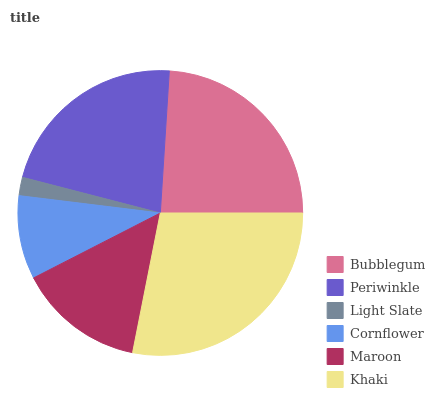Is Light Slate the minimum?
Answer yes or no. Yes. Is Khaki the maximum?
Answer yes or no. Yes. Is Periwinkle the minimum?
Answer yes or no. No. Is Periwinkle the maximum?
Answer yes or no. No. Is Bubblegum greater than Periwinkle?
Answer yes or no. Yes. Is Periwinkle less than Bubblegum?
Answer yes or no. Yes. Is Periwinkle greater than Bubblegum?
Answer yes or no. No. Is Bubblegum less than Periwinkle?
Answer yes or no. No. Is Periwinkle the high median?
Answer yes or no. Yes. Is Maroon the low median?
Answer yes or no. Yes. Is Light Slate the high median?
Answer yes or no. No. Is Light Slate the low median?
Answer yes or no. No. 